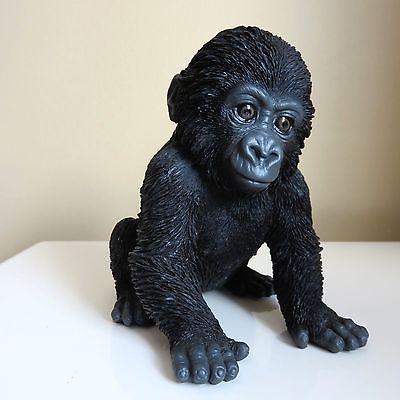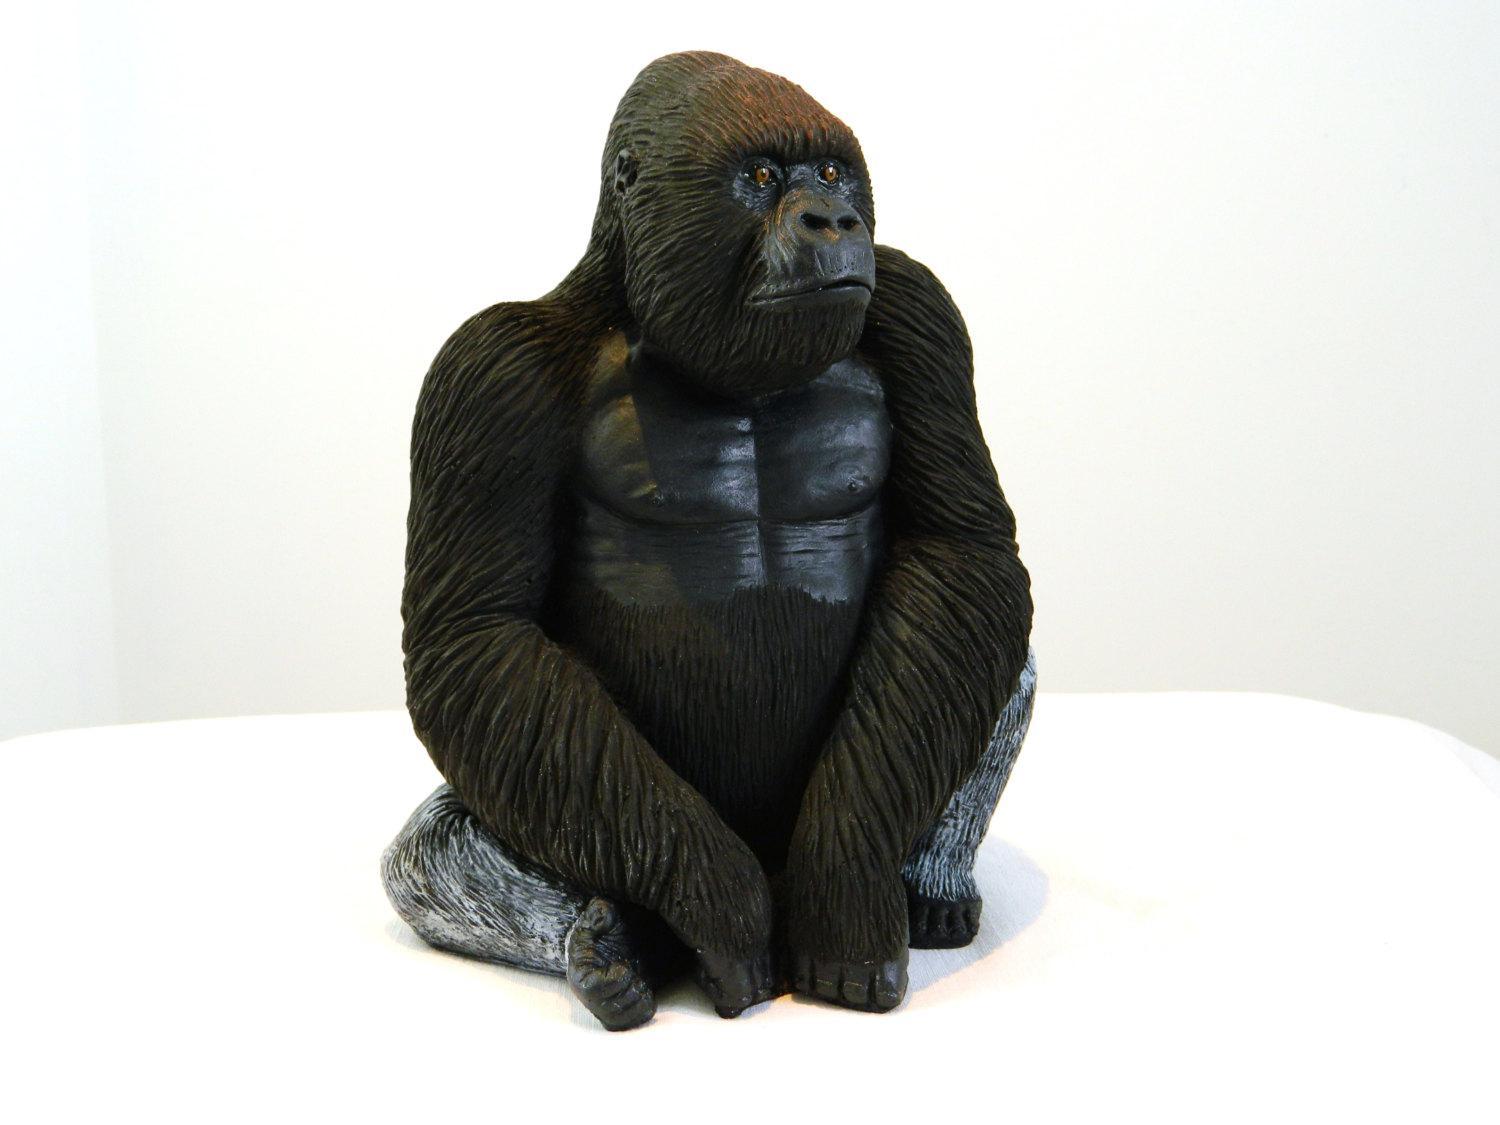The first image is the image on the left, the second image is the image on the right. Given the left and right images, does the statement "The combined images include a gorilla with crossed arms and a gorilla on all fours, and at least one gorilla depicted is a real animal." hold true? Answer yes or no. No. 